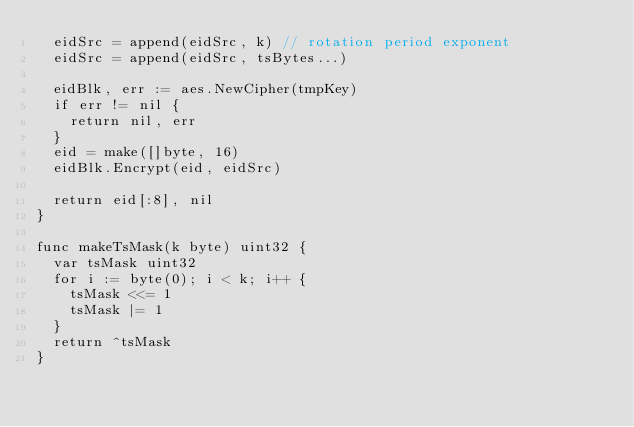<code> <loc_0><loc_0><loc_500><loc_500><_Go_>	eidSrc = append(eidSrc, k) // rotation period exponent
	eidSrc = append(eidSrc, tsBytes...)

	eidBlk, err := aes.NewCipher(tmpKey)
	if err != nil {
		return nil, err
	}
	eid = make([]byte, 16)
	eidBlk.Encrypt(eid, eidSrc)

	return eid[:8], nil
}

func makeTsMask(k byte) uint32 {
	var tsMask uint32
	for i := byte(0); i < k; i++ {
		tsMask <<= 1
		tsMask |= 1
	}
	return ^tsMask
}
</code> 